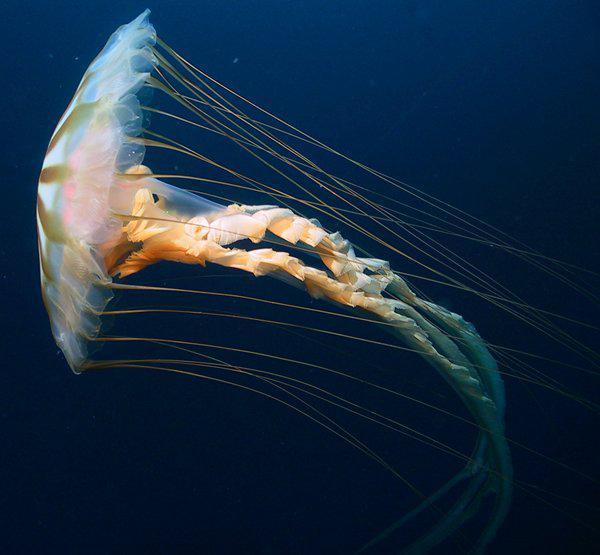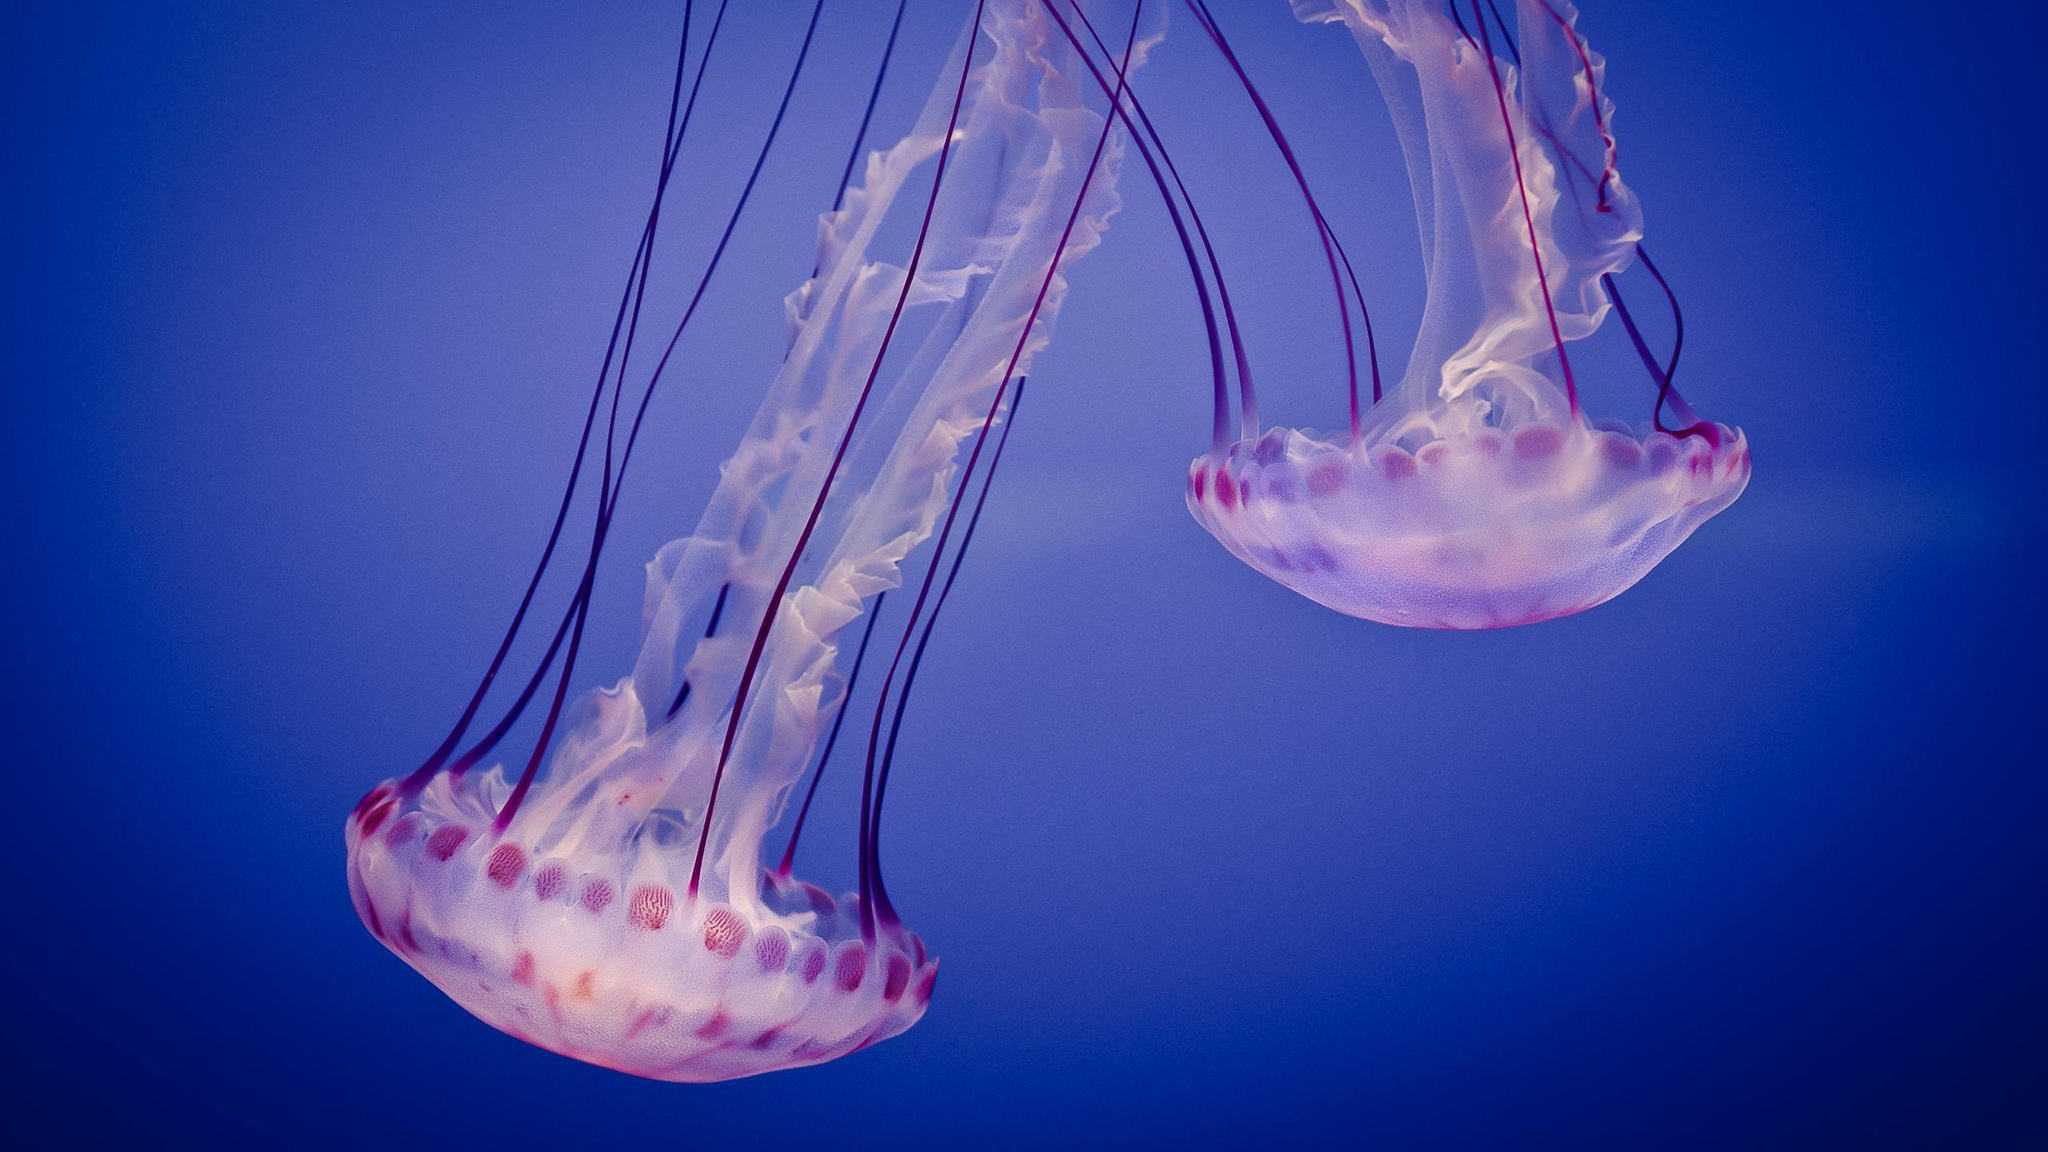The first image is the image on the left, the second image is the image on the right. For the images displayed, is the sentence "There are three jellyfish" factually correct? Answer yes or no. Yes. 